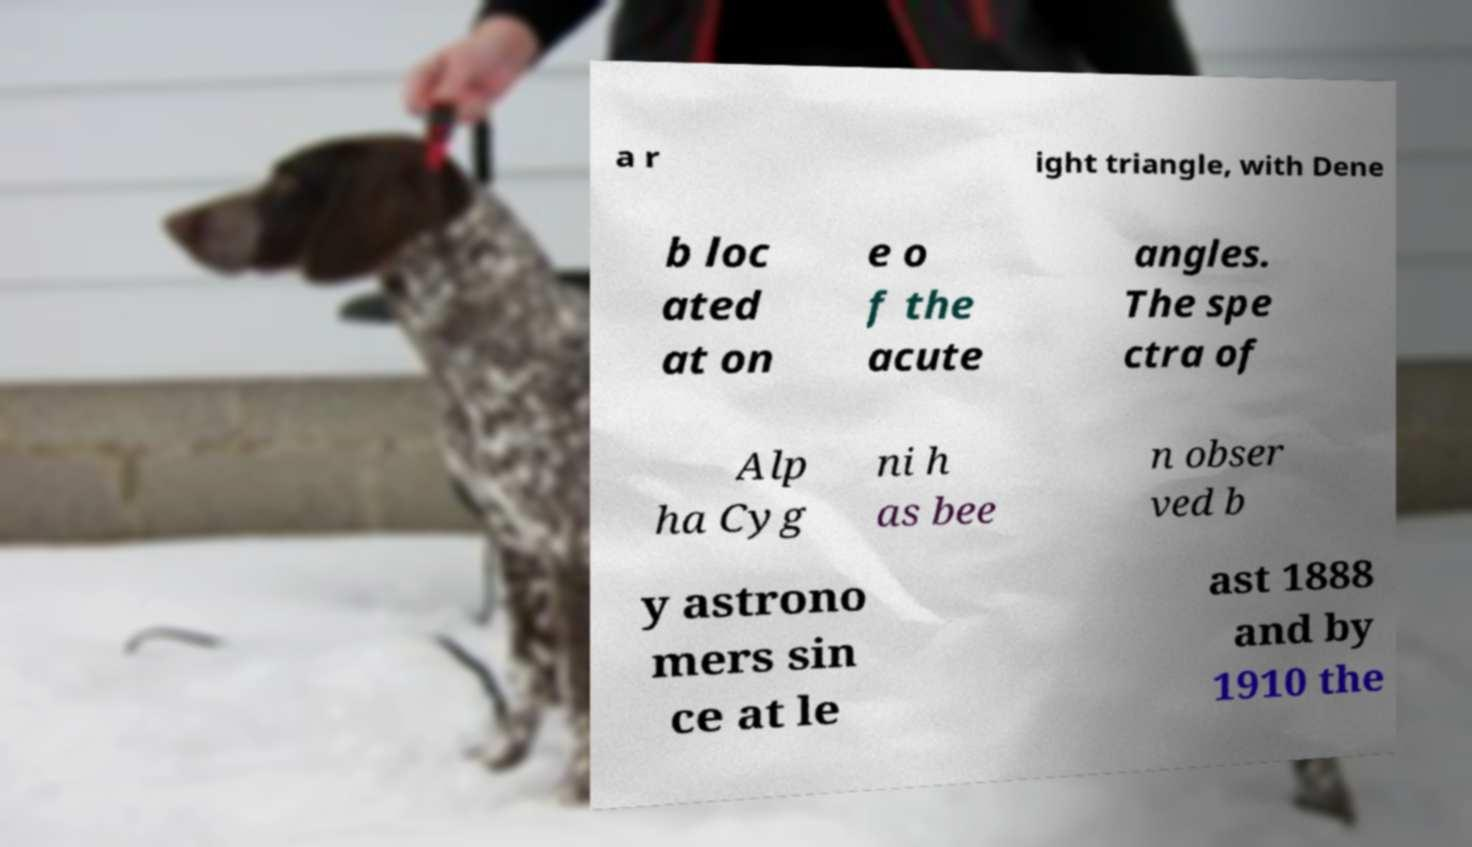What messages or text are displayed in this image? I need them in a readable, typed format. a r ight triangle, with Dene b loc ated at on e o f the acute angles. The spe ctra of Alp ha Cyg ni h as bee n obser ved b y astrono mers sin ce at le ast 1888 and by 1910 the 